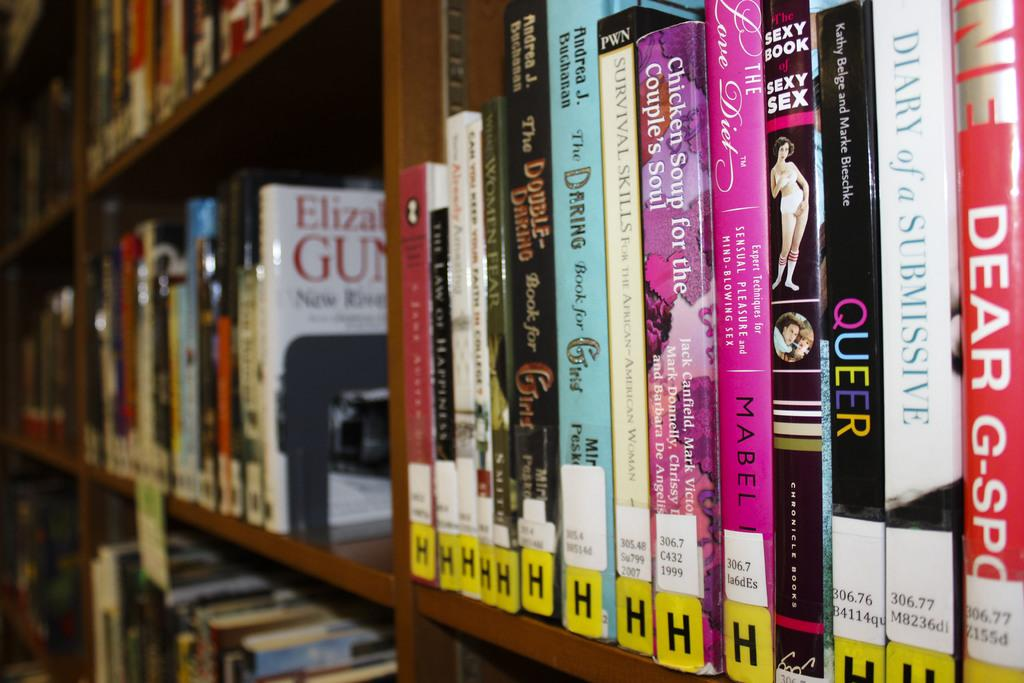<image>
Offer a succinct explanation of the picture presented. Several different books sitting in a library shelf with a yellow h label on the bottom of them. 